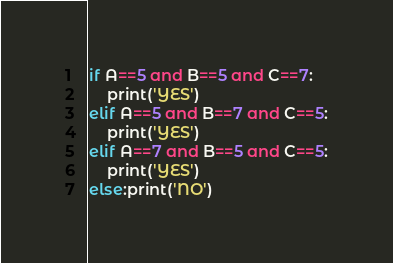<code> <loc_0><loc_0><loc_500><loc_500><_Python_>if A==5 and B==5 and C==7:
    print('YES')
elif A==5 and B==7 and C==5:
    print('YES')
elif A==7 and B==5 and C==5:
    print('YES')
else:print('NO')</code> 